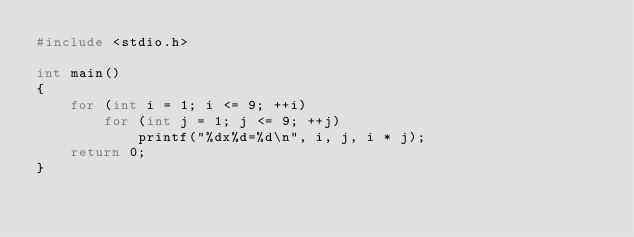Convert code to text. <code><loc_0><loc_0><loc_500><loc_500><_C++_>#include <stdio.h>

int main()
{
    for (int i = 1; i <= 9; ++i)
        for (int j = 1; j <= 9; ++j)
            printf("%dx%d=%d\n", i, j, i * j);
    return 0;
}</code> 